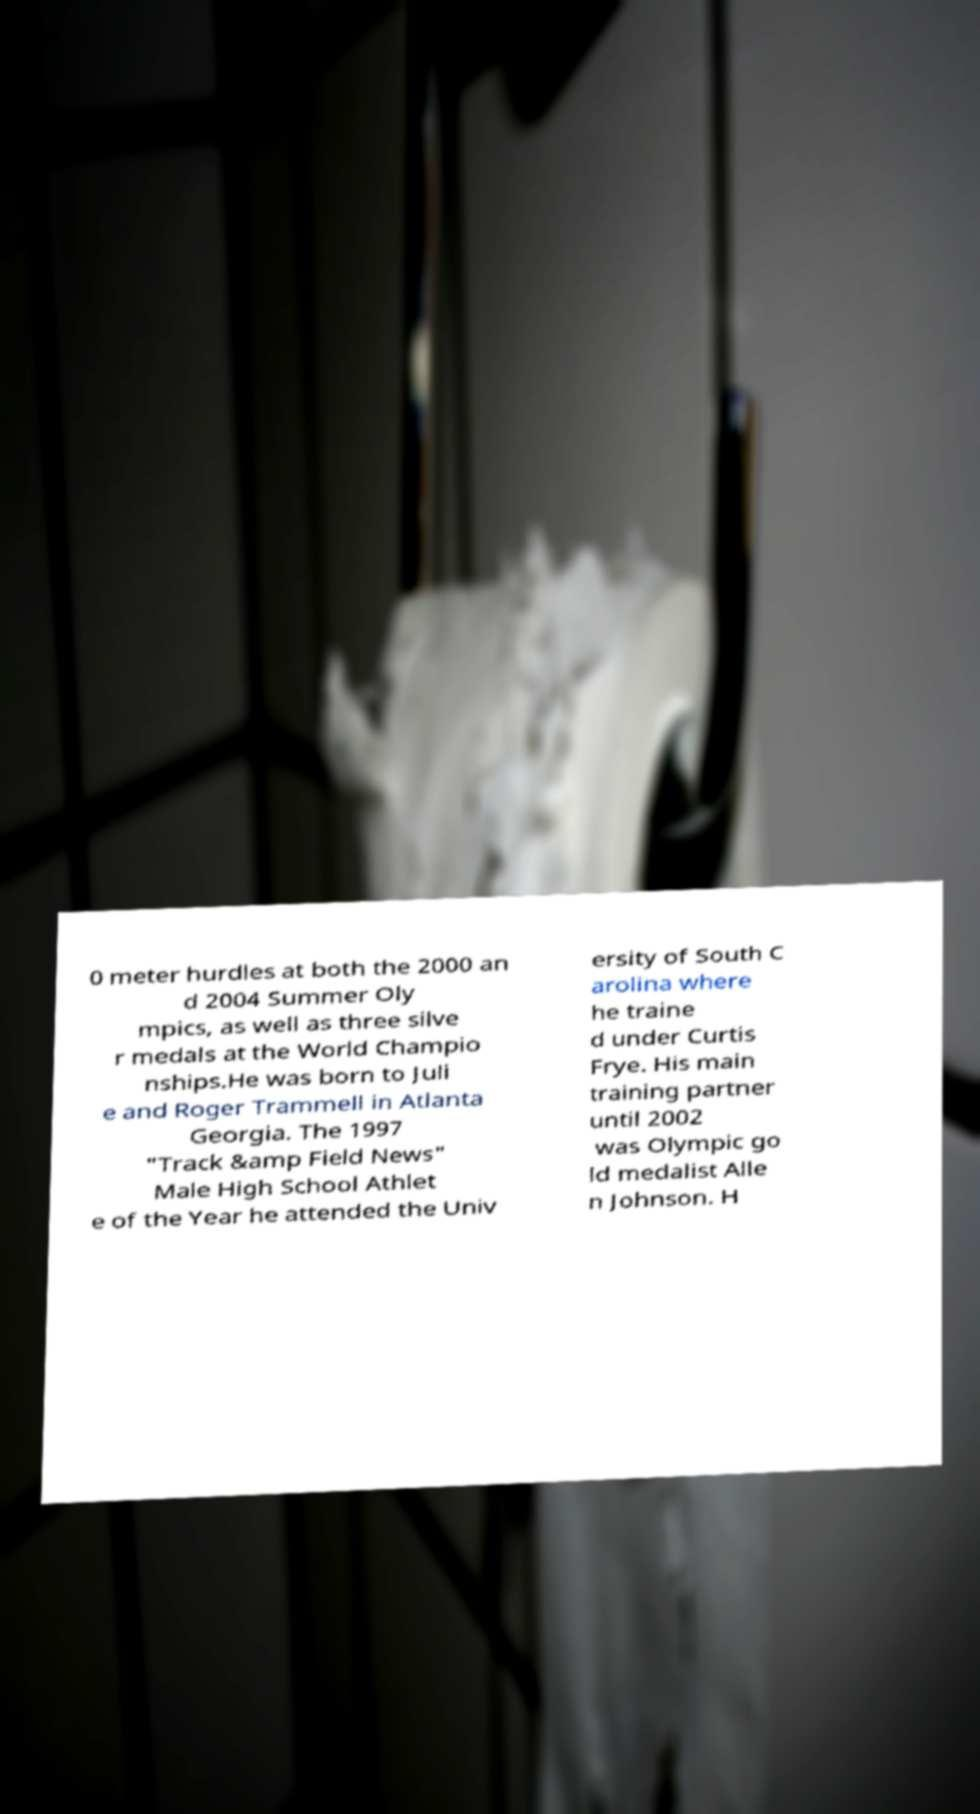Can you read and provide the text displayed in the image?This photo seems to have some interesting text. Can you extract and type it out for me? 0 meter hurdles at both the 2000 an d 2004 Summer Oly mpics, as well as three silve r medals at the World Champio nships.He was born to Juli e and Roger Trammell in Atlanta Georgia. The 1997 "Track &amp Field News" Male High School Athlet e of the Year he attended the Univ ersity of South C arolina where he traine d under Curtis Frye. His main training partner until 2002 was Olympic go ld medalist Alle n Johnson. H 